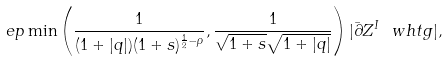Convert formula to latex. <formula><loc_0><loc_0><loc_500><loc_500>\ e p \min \left ( \frac { 1 } { ( 1 + | q | ) ( 1 + s ) ^ { \frac { 1 } { 2 } - \rho } } , \frac { 1 } { \sqrt { 1 + s } \sqrt { 1 + | q | } } \right ) | \bar { \partial } Z ^ { I } \ w h t g | ,</formula> 